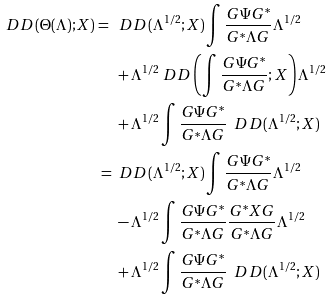<formula> <loc_0><loc_0><loc_500><loc_500>\ D D ( \Theta ( \Lambda ) ; X ) = \ & \ D D ( \Lambda ^ { 1 / 2 } ; X ) \int \frac { G \Psi G ^ { \ast } } { G ^ { \ast } \Lambda G } \Lambda ^ { 1 / 2 } \\ & + \Lambda ^ { 1 / 2 } \ D D \left ( \int \frac { G \Psi G ^ { \ast } } { G ^ { \ast } \Lambda G } ; X \right ) \Lambda ^ { 1 / 2 } \\ & + \Lambda ^ { 1 / 2 } \int \frac { G \Psi G ^ { \ast } } { G ^ { \ast } \Lambda G } \ \ D D ( \Lambda ^ { 1 / 2 } ; X ) \\ = \ & \ D D ( \Lambda ^ { 1 / 2 } ; X ) \int \frac { G \Psi G ^ { \ast } } { G ^ { \ast } \Lambda G } \Lambda ^ { 1 / 2 } \\ & - \Lambda ^ { 1 / 2 } \int \frac { G \Psi G ^ { \ast } } { G ^ { \ast } \Lambda G } \frac { G ^ { \ast } X G } { G ^ { \ast } \Lambda G } \Lambda ^ { 1 / 2 } \\ & + \Lambda ^ { 1 / 2 } \int \frac { G \Psi G ^ { \ast } } { G ^ { \ast } \Lambda G } \ \ D D ( \Lambda ^ { 1 / 2 } ; X )</formula> 